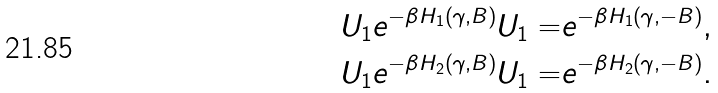Convert formula to latex. <formula><loc_0><loc_0><loc_500><loc_500>U _ { 1 } e ^ { - \beta H _ { 1 } ( \gamma , B ) } U _ { 1 } = & e ^ { - \beta H _ { 1 } ( \gamma , - B ) } , \\ U _ { 1 } e ^ { - \beta H _ { 2 } ( \gamma , B ) } U _ { 1 } = & e ^ { - \beta H _ { 2 } ( \gamma , - B ) } .</formula> 